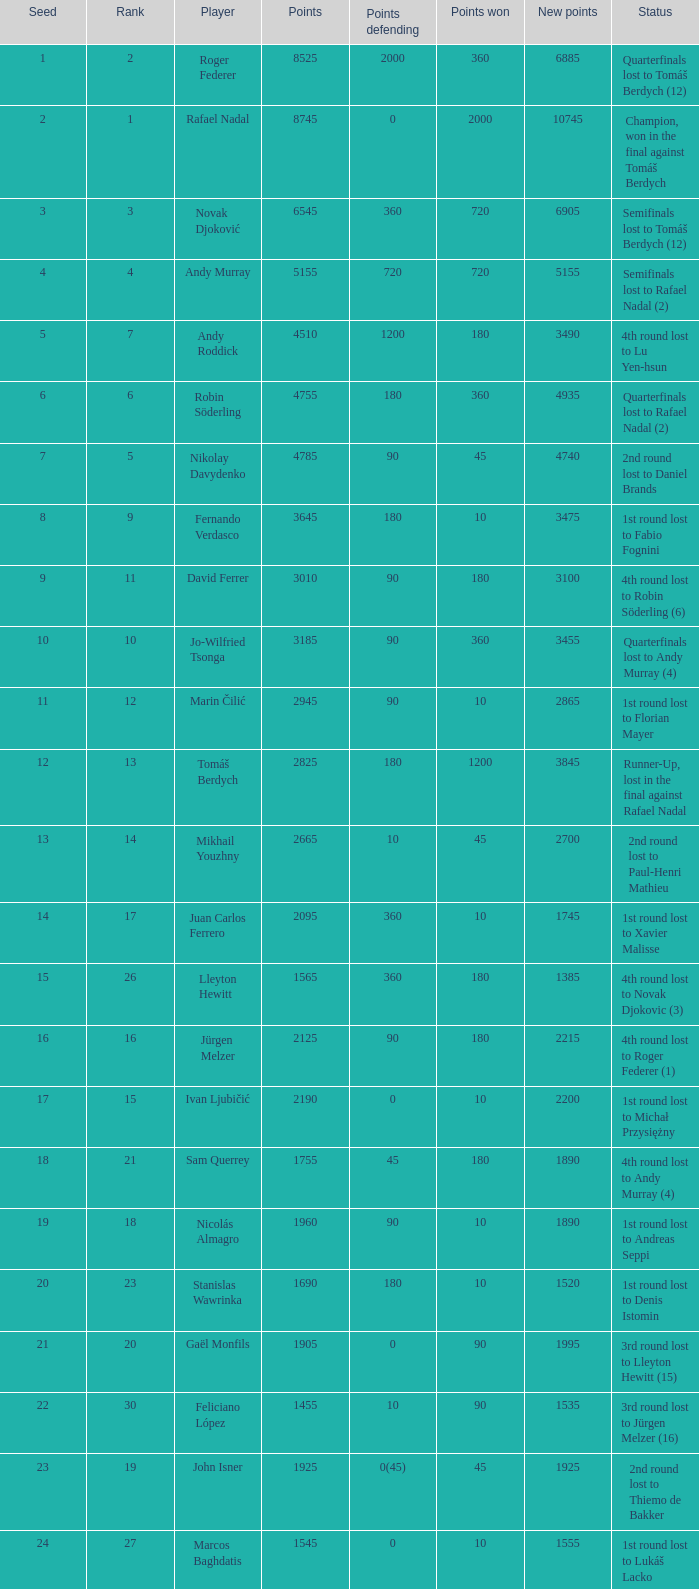Name the least new points for points defending is 1200 3490.0. 